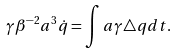<formula> <loc_0><loc_0><loc_500><loc_500>\gamma \beta ^ { - 2 } a ^ { 3 } \dot { q } = \int { a \gamma \triangle q d t } .</formula> 